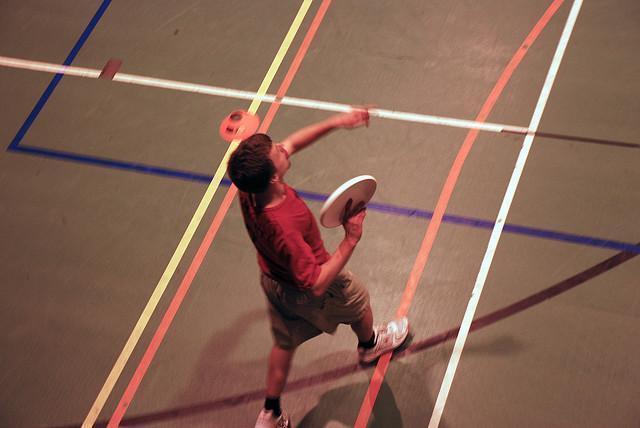How many oranges can be seen in the bottom box?
Give a very brief answer. 0. 